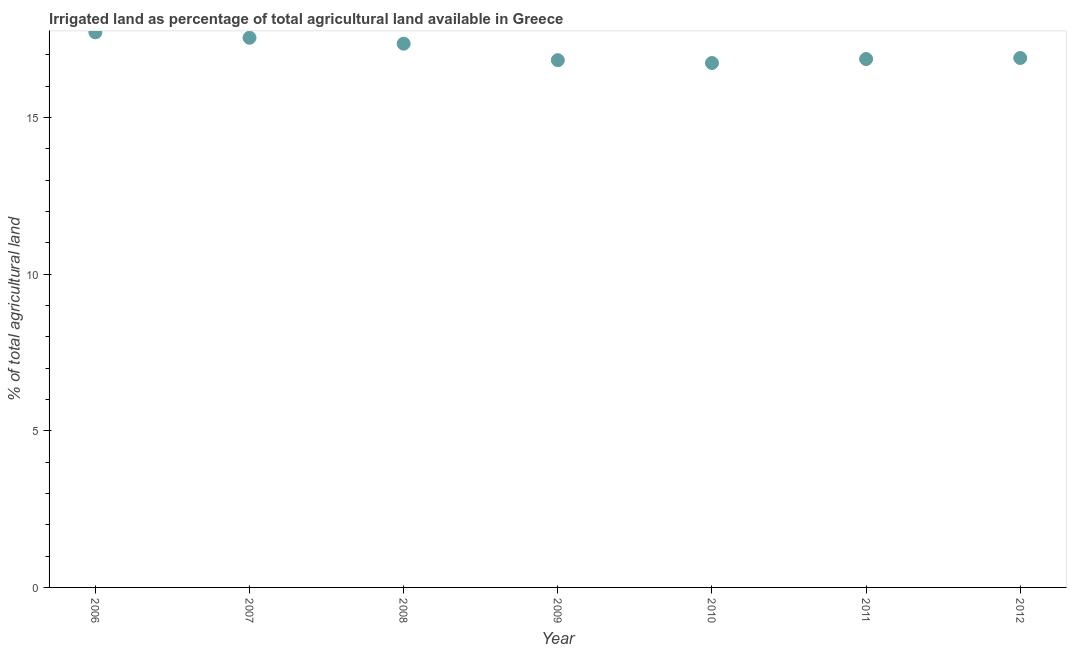What is the percentage of agricultural irrigated land in 2011?
Keep it short and to the point. 16.87. Across all years, what is the maximum percentage of agricultural irrigated land?
Give a very brief answer. 17.72. Across all years, what is the minimum percentage of agricultural irrigated land?
Ensure brevity in your answer.  16.74. In which year was the percentage of agricultural irrigated land minimum?
Offer a terse response. 2010. What is the sum of the percentage of agricultural irrigated land?
Give a very brief answer. 119.98. What is the difference between the percentage of agricultural irrigated land in 2006 and 2011?
Give a very brief answer. 0.85. What is the average percentage of agricultural irrigated land per year?
Offer a very short reply. 17.14. What is the median percentage of agricultural irrigated land?
Provide a short and direct response. 16.9. In how many years, is the percentage of agricultural irrigated land greater than 8 %?
Ensure brevity in your answer.  7. What is the ratio of the percentage of agricultural irrigated land in 2006 to that in 2008?
Keep it short and to the point. 1.02. What is the difference between the highest and the second highest percentage of agricultural irrigated land?
Your answer should be very brief. 0.17. What is the difference between the highest and the lowest percentage of agricultural irrigated land?
Your answer should be compact. 0.98. Does the graph contain any zero values?
Your answer should be compact. No. Does the graph contain grids?
Offer a very short reply. No. What is the title of the graph?
Provide a succinct answer. Irrigated land as percentage of total agricultural land available in Greece. What is the label or title of the Y-axis?
Your response must be concise. % of total agricultural land. What is the % of total agricultural land in 2006?
Provide a succinct answer. 17.72. What is the % of total agricultural land in 2007?
Give a very brief answer. 17.55. What is the % of total agricultural land in 2008?
Offer a very short reply. 17.36. What is the % of total agricultural land in 2009?
Keep it short and to the point. 16.83. What is the % of total agricultural land in 2010?
Provide a succinct answer. 16.74. What is the % of total agricultural land in 2011?
Your response must be concise. 16.87. What is the % of total agricultural land in 2012?
Offer a very short reply. 16.9. What is the difference between the % of total agricultural land in 2006 and 2007?
Offer a very short reply. 0.17. What is the difference between the % of total agricultural land in 2006 and 2008?
Make the answer very short. 0.36. What is the difference between the % of total agricultural land in 2006 and 2009?
Your answer should be very brief. 0.89. What is the difference between the % of total agricultural land in 2006 and 2010?
Keep it short and to the point. 0.98. What is the difference between the % of total agricultural land in 2006 and 2011?
Your response must be concise. 0.85. What is the difference between the % of total agricultural land in 2006 and 2012?
Your answer should be compact. 0.82. What is the difference between the % of total agricultural land in 2007 and 2008?
Ensure brevity in your answer.  0.19. What is the difference between the % of total agricultural land in 2007 and 2009?
Provide a short and direct response. 0.72. What is the difference between the % of total agricultural land in 2007 and 2010?
Provide a succinct answer. 0.81. What is the difference between the % of total agricultural land in 2007 and 2011?
Offer a terse response. 0.68. What is the difference between the % of total agricultural land in 2007 and 2012?
Provide a succinct answer. 0.65. What is the difference between the % of total agricultural land in 2008 and 2009?
Your answer should be very brief. 0.53. What is the difference between the % of total agricultural land in 2008 and 2010?
Offer a terse response. 0.62. What is the difference between the % of total agricultural land in 2008 and 2011?
Keep it short and to the point. 0.49. What is the difference between the % of total agricultural land in 2008 and 2012?
Provide a succinct answer. 0.46. What is the difference between the % of total agricultural land in 2009 and 2010?
Make the answer very short. 0.09. What is the difference between the % of total agricultural land in 2009 and 2011?
Offer a terse response. -0.04. What is the difference between the % of total agricultural land in 2009 and 2012?
Offer a very short reply. -0.07. What is the difference between the % of total agricultural land in 2010 and 2011?
Your answer should be very brief. -0.13. What is the difference between the % of total agricultural land in 2010 and 2012?
Your answer should be very brief. -0.16. What is the difference between the % of total agricultural land in 2011 and 2012?
Provide a succinct answer. -0.03. What is the ratio of the % of total agricultural land in 2006 to that in 2008?
Make the answer very short. 1.02. What is the ratio of the % of total agricultural land in 2006 to that in 2009?
Provide a succinct answer. 1.05. What is the ratio of the % of total agricultural land in 2006 to that in 2010?
Ensure brevity in your answer.  1.06. What is the ratio of the % of total agricultural land in 2006 to that in 2011?
Your answer should be compact. 1.05. What is the ratio of the % of total agricultural land in 2006 to that in 2012?
Your response must be concise. 1.05. What is the ratio of the % of total agricultural land in 2007 to that in 2008?
Give a very brief answer. 1.01. What is the ratio of the % of total agricultural land in 2007 to that in 2009?
Provide a short and direct response. 1.04. What is the ratio of the % of total agricultural land in 2007 to that in 2010?
Ensure brevity in your answer.  1.05. What is the ratio of the % of total agricultural land in 2007 to that in 2012?
Provide a succinct answer. 1.04. What is the ratio of the % of total agricultural land in 2008 to that in 2009?
Offer a very short reply. 1.03. What is the ratio of the % of total agricultural land in 2008 to that in 2010?
Offer a very short reply. 1.04. What is the ratio of the % of total agricultural land in 2008 to that in 2012?
Your response must be concise. 1.03. What is the ratio of the % of total agricultural land in 2009 to that in 2010?
Provide a short and direct response. 1. What is the ratio of the % of total agricultural land in 2010 to that in 2011?
Your answer should be compact. 0.99. What is the ratio of the % of total agricultural land in 2010 to that in 2012?
Give a very brief answer. 0.99. What is the ratio of the % of total agricultural land in 2011 to that in 2012?
Your answer should be very brief. 1. 